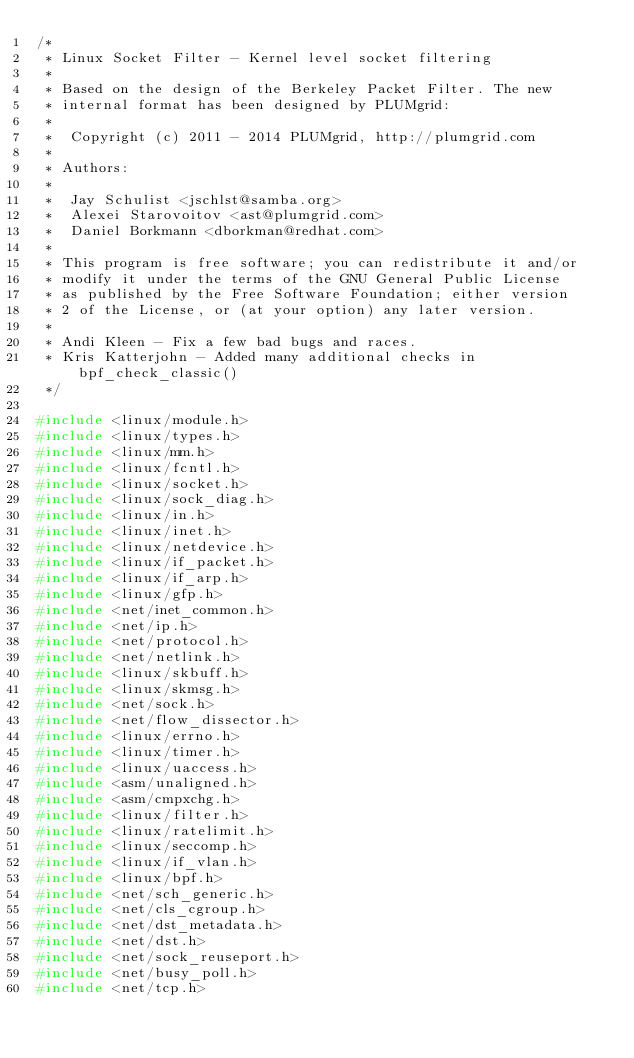Convert code to text. <code><loc_0><loc_0><loc_500><loc_500><_C_>/*
 * Linux Socket Filter - Kernel level socket filtering
 *
 * Based on the design of the Berkeley Packet Filter. The new
 * internal format has been designed by PLUMgrid:
 *
 *	Copyright (c) 2011 - 2014 PLUMgrid, http://plumgrid.com
 *
 * Authors:
 *
 *	Jay Schulist <jschlst@samba.org>
 *	Alexei Starovoitov <ast@plumgrid.com>
 *	Daniel Borkmann <dborkman@redhat.com>
 *
 * This program is free software; you can redistribute it and/or
 * modify it under the terms of the GNU General Public License
 * as published by the Free Software Foundation; either version
 * 2 of the License, or (at your option) any later version.
 *
 * Andi Kleen - Fix a few bad bugs and races.
 * Kris Katterjohn - Added many additional checks in bpf_check_classic()
 */

#include <linux/module.h>
#include <linux/types.h>
#include <linux/mm.h>
#include <linux/fcntl.h>
#include <linux/socket.h>
#include <linux/sock_diag.h>
#include <linux/in.h>
#include <linux/inet.h>
#include <linux/netdevice.h>
#include <linux/if_packet.h>
#include <linux/if_arp.h>
#include <linux/gfp.h>
#include <net/inet_common.h>
#include <net/ip.h>
#include <net/protocol.h>
#include <net/netlink.h>
#include <linux/skbuff.h>
#include <linux/skmsg.h>
#include <net/sock.h>
#include <net/flow_dissector.h>
#include <linux/errno.h>
#include <linux/timer.h>
#include <linux/uaccess.h>
#include <asm/unaligned.h>
#include <asm/cmpxchg.h>
#include <linux/filter.h>
#include <linux/ratelimit.h>
#include <linux/seccomp.h>
#include <linux/if_vlan.h>
#include <linux/bpf.h>
#include <net/sch_generic.h>
#include <net/cls_cgroup.h>
#include <net/dst_metadata.h>
#include <net/dst.h>
#include <net/sock_reuseport.h>
#include <net/busy_poll.h>
#include <net/tcp.h></code> 